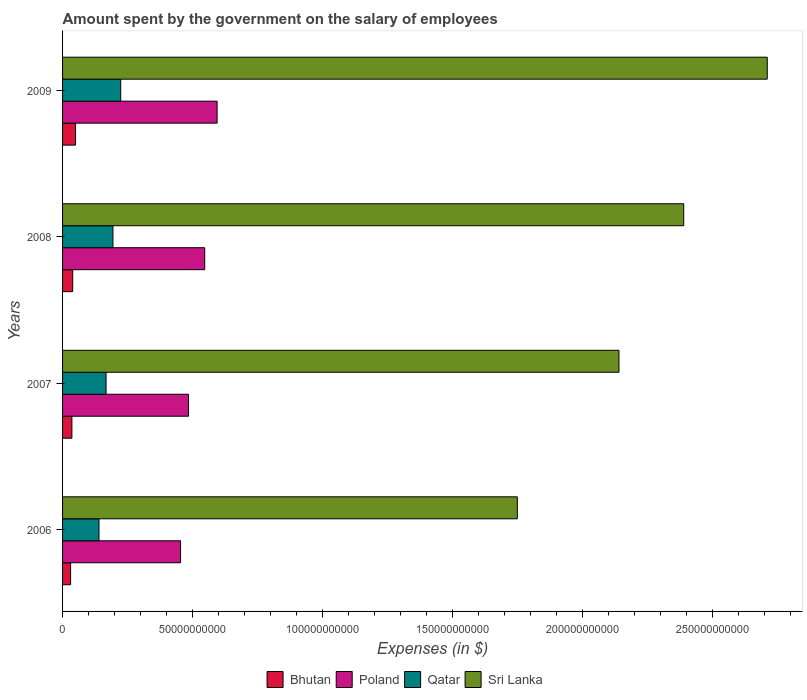What is the label of the 1st group of bars from the top?
Provide a short and direct response. 2009. What is the amount spent on the salary of employees by the government in Qatar in 2007?
Your response must be concise. 1.67e+1. Across all years, what is the maximum amount spent on the salary of employees by the government in Poland?
Your answer should be compact. 5.95e+1. Across all years, what is the minimum amount spent on the salary of employees by the government in Sri Lanka?
Provide a short and direct response. 1.75e+11. In which year was the amount spent on the salary of employees by the government in Poland minimum?
Make the answer very short. 2006. What is the total amount spent on the salary of employees by the government in Qatar in the graph?
Give a very brief answer. 7.25e+1. What is the difference between the amount spent on the salary of employees by the government in Sri Lanka in 2006 and that in 2009?
Your answer should be very brief. -9.62e+1. What is the difference between the amount spent on the salary of employees by the government in Poland in 2006 and the amount spent on the salary of employees by the government in Sri Lanka in 2009?
Offer a terse response. -2.26e+11. What is the average amount spent on the salary of employees by the government in Qatar per year?
Your response must be concise. 1.81e+1. In the year 2009, what is the difference between the amount spent on the salary of employees by the government in Qatar and amount spent on the salary of employees by the government in Sri Lanka?
Make the answer very short. -2.49e+11. What is the ratio of the amount spent on the salary of employees by the government in Bhutan in 2008 to that in 2009?
Provide a succinct answer. 0.78. Is the difference between the amount spent on the salary of employees by the government in Qatar in 2006 and 2008 greater than the difference between the amount spent on the salary of employees by the government in Sri Lanka in 2006 and 2008?
Your answer should be very brief. Yes. What is the difference between the highest and the second highest amount spent on the salary of employees by the government in Sri Lanka?
Offer a terse response. 3.22e+1. What is the difference between the highest and the lowest amount spent on the salary of employees by the government in Qatar?
Your answer should be compact. 8.36e+09. In how many years, is the amount spent on the salary of employees by the government in Qatar greater than the average amount spent on the salary of employees by the government in Qatar taken over all years?
Offer a terse response. 2. What does the 2nd bar from the top in 2008 represents?
Offer a very short reply. Qatar. What does the 4th bar from the bottom in 2008 represents?
Offer a very short reply. Sri Lanka. Is it the case that in every year, the sum of the amount spent on the salary of employees by the government in Poland and amount spent on the salary of employees by the government in Qatar is greater than the amount spent on the salary of employees by the government in Sri Lanka?
Offer a terse response. No. What is the difference between two consecutive major ticks on the X-axis?
Your response must be concise. 5.00e+1. Are the values on the major ticks of X-axis written in scientific E-notation?
Provide a succinct answer. No. Does the graph contain any zero values?
Offer a very short reply. No. Where does the legend appear in the graph?
Ensure brevity in your answer.  Bottom center. How many legend labels are there?
Offer a terse response. 4. What is the title of the graph?
Offer a very short reply. Amount spent by the government on the salary of employees. What is the label or title of the X-axis?
Ensure brevity in your answer.  Expenses (in $). What is the Expenses (in $) of Bhutan in 2006?
Offer a terse response. 3.09e+09. What is the Expenses (in $) in Poland in 2006?
Offer a terse response. 4.54e+1. What is the Expenses (in $) in Qatar in 2006?
Provide a short and direct response. 1.40e+1. What is the Expenses (in $) in Sri Lanka in 2006?
Your answer should be very brief. 1.75e+11. What is the Expenses (in $) of Bhutan in 2007?
Your answer should be very brief. 3.60e+09. What is the Expenses (in $) of Poland in 2007?
Your answer should be compact. 4.85e+1. What is the Expenses (in $) of Qatar in 2007?
Ensure brevity in your answer.  1.67e+1. What is the Expenses (in $) of Sri Lanka in 2007?
Your answer should be compact. 2.14e+11. What is the Expenses (in $) in Bhutan in 2008?
Your answer should be very brief. 3.90e+09. What is the Expenses (in $) of Poland in 2008?
Offer a very short reply. 5.47e+1. What is the Expenses (in $) of Qatar in 2008?
Provide a succinct answer. 1.94e+1. What is the Expenses (in $) in Sri Lanka in 2008?
Ensure brevity in your answer.  2.39e+11. What is the Expenses (in $) of Bhutan in 2009?
Give a very brief answer. 4.99e+09. What is the Expenses (in $) of Poland in 2009?
Provide a short and direct response. 5.95e+1. What is the Expenses (in $) in Qatar in 2009?
Your response must be concise. 2.24e+1. What is the Expenses (in $) in Sri Lanka in 2009?
Offer a terse response. 2.71e+11. Across all years, what is the maximum Expenses (in $) in Bhutan?
Offer a terse response. 4.99e+09. Across all years, what is the maximum Expenses (in $) in Poland?
Give a very brief answer. 5.95e+1. Across all years, what is the maximum Expenses (in $) in Qatar?
Your response must be concise. 2.24e+1. Across all years, what is the maximum Expenses (in $) of Sri Lanka?
Your response must be concise. 2.71e+11. Across all years, what is the minimum Expenses (in $) of Bhutan?
Ensure brevity in your answer.  3.09e+09. Across all years, what is the minimum Expenses (in $) in Poland?
Ensure brevity in your answer.  4.54e+1. Across all years, what is the minimum Expenses (in $) in Qatar?
Offer a terse response. 1.40e+1. Across all years, what is the minimum Expenses (in $) in Sri Lanka?
Offer a very short reply. 1.75e+11. What is the total Expenses (in $) of Bhutan in the graph?
Ensure brevity in your answer.  1.56e+1. What is the total Expenses (in $) in Poland in the graph?
Offer a very short reply. 2.08e+11. What is the total Expenses (in $) in Qatar in the graph?
Your answer should be very brief. 7.25e+1. What is the total Expenses (in $) in Sri Lanka in the graph?
Ensure brevity in your answer.  8.99e+11. What is the difference between the Expenses (in $) of Bhutan in 2006 and that in 2007?
Make the answer very short. -5.02e+08. What is the difference between the Expenses (in $) in Poland in 2006 and that in 2007?
Offer a terse response. -3.07e+09. What is the difference between the Expenses (in $) of Qatar in 2006 and that in 2007?
Provide a succinct answer. -2.72e+09. What is the difference between the Expenses (in $) in Sri Lanka in 2006 and that in 2007?
Give a very brief answer. -3.91e+1. What is the difference between the Expenses (in $) of Bhutan in 2006 and that in 2008?
Provide a short and direct response. -8.10e+08. What is the difference between the Expenses (in $) in Poland in 2006 and that in 2008?
Give a very brief answer. -9.30e+09. What is the difference between the Expenses (in $) in Qatar in 2006 and that in 2008?
Your answer should be very brief. -5.37e+09. What is the difference between the Expenses (in $) in Sri Lanka in 2006 and that in 2008?
Provide a short and direct response. -6.40e+1. What is the difference between the Expenses (in $) of Bhutan in 2006 and that in 2009?
Ensure brevity in your answer.  -1.90e+09. What is the difference between the Expenses (in $) of Poland in 2006 and that in 2009?
Give a very brief answer. -1.41e+1. What is the difference between the Expenses (in $) of Qatar in 2006 and that in 2009?
Provide a succinct answer. -8.36e+09. What is the difference between the Expenses (in $) of Sri Lanka in 2006 and that in 2009?
Your answer should be very brief. -9.62e+1. What is the difference between the Expenses (in $) of Bhutan in 2007 and that in 2008?
Your response must be concise. -3.08e+08. What is the difference between the Expenses (in $) in Poland in 2007 and that in 2008?
Your response must be concise. -6.23e+09. What is the difference between the Expenses (in $) in Qatar in 2007 and that in 2008?
Keep it short and to the point. -2.65e+09. What is the difference between the Expenses (in $) in Sri Lanka in 2007 and that in 2008?
Offer a very short reply. -2.49e+1. What is the difference between the Expenses (in $) of Bhutan in 2007 and that in 2009?
Provide a short and direct response. -1.40e+09. What is the difference between the Expenses (in $) of Poland in 2007 and that in 2009?
Your response must be concise. -1.10e+1. What is the difference between the Expenses (in $) in Qatar in 2007 and that in 2009?
Ensure brevity in your answer.  -5.64e+09. What is the difference between the Expenses (in $) in Sri Lanka in 2007 and that in 2009?
Give a very brief answer. -5.71e+1. What is the difference between the Expenses (in $) of Bhutan in 2008 and that in 2009?
Ensure brevity in your answer.  -1.09e+09. What is the difference between the Expenses (in $) in Poland in 2008 and that in 2009?
Offer a very short reply. -4.77e+09. What is the difference between the Expenses (in $) of Qatar in 2008 and that in 2009?
Your answer should be very brief. -2.99e+09. What is the difference between the Expenses (in $) of Sri Lanka in 2008 and that in 2009?
Offer a terse response. -3.22e+1. What is the difference between the Expenses (in $) of Bhutan in 2006 and the Expenses (in $) of Poland in 2007?
Your answer should be very brief. -4.54e+1. What is the difference between the Expenses (in $) in Bhutan in 2006 and the Expenses (in $) in Qatar in 2007?
Ensure brevity in your answer.  -1.36e+1. What is the difference between the Expenses (in $) of Bhutan in 2006 and the Expenses (in $) of Sri Lanka in 2007?
Make the answer very short. -2.11e+11. What is the difference between the Expenses (in $) of Poland in 2006 and the Expenses (in $) of Qatar in 2007?
Your answer should be very brief. 2.87e+1. What is the difference between the Expenses (in $) of Poland in 2006 and the Expenses (in $) of Sri Lanka in 2007?
Make the answer very short. -1.69e+11. What is the difference between the Expenses (in $) in Qatar in 2006 and the Expenses (in $) in Sri Lanka in 2007?
Offer a terse response. -2.00e+11. What is the difference between the Expenses (in $) of Bhutan in 2006 and the Expenses (in $) of Poland in 2008?
Ensure brevity in your answer.  -5.16e+1. What is the difference between the Expenses (in $) of Bhutan in 2006 and the Expenses (in $) of Qatar in 2008?
Give a very brief answer. -1.63e+1. What is the difference between the Expenses (in $) in Bhutan in 2006 and the Expenses (in $) in Sri Lanka in 2008?
Provide a succinct answer. -2.36e+11. What is the difference between the Expenses (in $) in Poland in 2006 and the Expenses (in $) in Qatar in 2008?
Offer a terse response. 2.60e+1. What is the difference between the Expenses (in $) in Poland in 2006 and the Expenses (in $) in Sri Lanka in 2008?
Your response must be concise. -1.94e+11. What is the difference between the Expenses (in $) in Qatar in 2006 and the Expenses (in $) in Sri Lanka in 2008?
Provide a succinct answer. -2.25e+11. What is the difference between the Expenses (in $) in Bhutan in 2006 and the Expenses (in $) in Poland in 2009?
Your response must be concise. -5.64e+1. What is the difference between the Expenses (in $) of Bhutan in 2006 and the Expenses (in $) of Qatar in 2009?
Your answer should be compact. -1.93e+1. What is the difference between the Expenses (in $) of Bhutan in 2006 and the Expenses (in $) of Sri Lanka in 2009?
Your answer should be very brief. -2.68e+11. What is the difference between the Expenses (in $) in Poland in 2006 and the Expenses (in $) in Qatar in 2009?
Provide a succinct answer. 2.30e+1. What is the difference between the Expenses (in $) in Poland in 2006 and the Expenses (in $) in Sri Lanka in 2009?
Your response must be concise. -2.26e+11. What is the difference between the Expenses (in $) in Qatar in 2006 and the Expenses (in $) in Sri Lanka in 2009?
Offer a terse response. -2.57e+11. What is the difference between the Expenses (in $) of Bhutan in 2007 and the Expenses (in $) of Poland in 2008?
Make the answer very short. -5.11e+1. What is the difference between the Expenses (in $) of Bhutan in 2007 and the Expenses (in $) of Qatar in 2008?
Ensure brevity in your answer.  -1.58e+1. What is the difference between the Expenses (in $) of Bhutan in 2007 and the Expenses (in $) of Sri Lanka in 2008?
Your answer should be compact. -2.35e+11. What is the difference between the Expenses (in $) in Poland in 2007 and the Expenses (in $) in Qatar in 2008?
Ensure brevity in your answer.  2.91e+1. What is the difference between the Expenses (in $) in Poland in 2007 and the Expenses (in $) in Sri Lanka in 2008?
Offer a terse response. -1.91e+11. What is the difference between the Expenses (in $) of Qatar in 2007 and the Expenses (in $) of Sri Lanka in 2008?
Ensure brevity in your answer.  -2.22e+11. What is the difference between the Expenses (in $) of Bhutan in 2007 and the Expenses (in $) of Poland in 2009?
Give a very brief answer. -5.59e+1. What is the difference between the Expenses (in $) in Bhutan in 2007 and the Expenses (in $) in Qatar in 2009?
Ensure brevity in your answer.  -1.88e+1. What is the difference between the Expenses (in $) in Bhutan in 2007 and the Expenses (in $) in Sri Lanka in 2009?
Make the answer very short. -2.68e+11. What is the difference between the Expenses (in $) in Poland in 2007 and the Expenses (in $) in Qatar in 2009?
Your answer should be very brief. 2.61e+1. What is the difference between the Expenses (in $) in Poland in 2007 and the Expenses (in $) in Sri Lanka in 2009?
Give a very brief answer. -2.23e+11. What is the difference between the Expenses (in $) of Qatar in 2007 and the Expenses (in $) of Sri Lanka in 2009?
Offer a very short reply. -2.54e+11. What is the difference between the Expenses (in $) of Bhutan in 2008 and the Expenses (in $) of Poland in 2009?
Provide a short and direct response. -5.56e+1. What is the difference between the Expenses (in $) of Bhutan in 2008 and the Expenses (in $) of Qatar in 2009?
Your answer should be compact. -1.85e+1. What is the difference between the Expenses (in $) of Bhutan in 2008 and the Expenses (in $) of Sri Lanka in 2009?
Give a very brief answer. -2.67e+11. What is the difference between the Expenses (in $) in Poland in 2008 and the Expenses (in $) in Qatar in 2009?
Give a very brief answer. 3.23e+1. What is the difference between the Expenses (in $) of Poland in 2008 and the Expenses (in $) of Sri Lanka in 2009?
Make the answer very short. -2.17e+11. What is the difference between the Expenses (in $) of Qatar in 2008 and the Expenses (in $) of Sri Lanka in 2009?
Your answer should be very brief. -2.52e+11. What is the average Expenses (in $) of Bhutan per year?
Your response must be concise. 3.90e+09. What is the average Expenses (in $) in Poland per year?
Make the answer very short. 5.20e+1. What is the average Expenses (in $) in Qatar per year?
Provide a short and direct response. 1.81e+1. What is the average Expenses (in $) in Sri Lanka per year?
Keep it short and to the point. 2.25e+11. In the year 2006, what is the difference between the Expenses (in $) in Bhutan and Expenses (in $) in Poland?
Provide a succinct answer. -4.23e+1. In the year 2006, what is the difference between the Expenses (in $) in Bhutan and Expenses (in $) in Qatar?
Your answer should be compact. -1.09e+1. In the year 2006, what is the difference between the Expenses (in $) in Bhutan and Expenses (in $) in Sri Lanka?
Provide a succinct answer. -1.72e+11. In the year 2006, what is the difference between the Expenses (in $) in Poland and Expenses (in $) in Qatar?
Provide a succinct answer. 3.14e+1. In the year 2006, what is the difference between the Expenses (in $) in Poland and Expenses (in $) in Sri Lanka?
Your response must be concise. -1.30e+11. In the year 2006, what is the difference between the Expenses (in $) of Qatar and Expenses (in $) of Sri Lanka?
Offer a terse response. -1.61e+11. In the year 2007, what is the difference between the Expenses (in $) of Bhutan and Expenses (in $) of Poland?
Keep it short and to the point. -4.49e+1. In the year 2007, what is the difference between the Expenses (in $) of Bhutan and Expenses (in $) of Qatar?
Keep it short and to the point. -1.31e+1. In the year 2007, what is the difference between the Expenses (in $) of Bhutan and Expenses (in $) of Sri Lanka?
Provide a short and direct response. -2.11e+11. In the year 2007, what is the difference between the Expenses (in $) in Poland and Expenses (in $) in Qatar?
Keep it short and to the point. 3.17e+1. In the year 2007, what is the difference between the Expenses (in $) in Poland and Expenses (in $) in Sri Lanka?
Keep it short and to the point. -1.66e+11. In the year 2007, what is the difference between the Expenses (in $) of Qatar and Expenses (in $) of Sri Lanka?
Provide a short and direct response. -1.97e+11. In the year 2008, what is the difference between the Expenses (in $) of Bhutan and Expenses (in $) of Poland?
Your response must be concise. -5.08e+1. In the year 2008, what is the difference between the Expenses (in $) in Bhutan and Expenses (in $) in Qatar?
Make the answer very short. -1.55e+1. In the year 2008, what is the difference between the Expenses (in $) of Bhutan and Expenses (in $) of Sri Lanka?
Your response must be concise. -2.35e+11. In the year 2008, what is the difference between the Expenses (in $) of Poland and Expenses (in $) of Qatar?
Offer a terse response. 3.53e+1. In the year 2008, what is the difference between the Expenses (in $) in Poland and Expenses (in $) in Sri Lanka?
Keep it short and to the point. -1.84e+11. In the year 2008, what is the difference between the Expenses (in $) in Qatar and Expenses (in $) in Sri Lanka?
Give a very brief answer. -2.20e+11. In the year 2009, what is the difference between the Expenses (in $) of Bhutan and Expenses (in $) of Poland?
Keep it short and to the point. -5.45e+1. In the year 2009, what is the difference between the Expenses (in $) of Bhutan and Expenses (in $) of Qatar?
Provide a short and direct response. -1.74e+1. In the year 2009, what is the difference between the Expenses (in $) of Bhutan and Expenses (in $) of Sri Lanka?
Offer a terse response. -2.66e+11. In the year 2009, what is the difference between the Expenses (in $) in Poland and Expenses (in $) in Qatar?
Keep it short and to the point. 3.71e+1. In the year 2009, what is the difference between the Expenses (in $) in Poland and Expenses (in $) in Sri Lanka?
Provide a short and direct response. -2.12e+11. In the year 2009, what is the difference between the Expenses (in $) of Qatar and Expenses (in $) of Sri Lanka?
Provide a short and direct response. -2.49e+11. What is the ratio of the Expenses (in $) in Bhutan in 2006 to that in 2007?
Ensure brevity in your answer.  0.86. What is the ratio of the Expenses (in $) in Poland in 2006 to that in 2007?
Your answer should be very brief. 0.94. What is the ratio of the Expenses (in $) of Qatar in 2006 to that in 2007?
Your response must be concise. 0.84. What is the ratio of the Expenses (in $) of Sri Lanka in 2006 to that in 2007?
Make the answer very short. 0.82. What is the ratio of the Expenses (in $) in Bhutan in 2006 to that in 2008?
Keep it short and to the point. 0.79. What is the ratio of the Expenses (in $) in Poland in 2006 to that in 2008?
Ensure brevity in your answer.  0.83. What is the ratio of the Expenses (in $) in Qatar in 2006 to that in 2008?
Your response must be concise. 0.72. What is the ratio of the Expenses (in $) in Sri Lanka in 2006 to that in 2008?
Your answer should be very brief. 0.73. What is the ratio of the Expenses (in $) of Bhutan in 2006 to that in 2009?
Offer a very short reply. 0.62. What is the ratio of the Expenses (in $) in Poland in 2006 to that in 2009?
Your answer should be very brief. 0.76. What is the ratio of the Expenses (in $) of Qatar in 2006 to that in 2009?
Give a very brief answer. 0.63. What is the ratio of the Expenses (in $) in Sri Lanka in 2006 to that in 2009?
Keep it short and to the point. 0.65. What is the ratio of the Expenses (in $) in Bhutan in 2007 to that in 2008?
Provide a short and direct response. 0.92. What is the ratio of the Expenses (in $) of Poland in 2007 to that in 2008?
Give a very brief answer. 0.89. What is the ratio of the Expenses (in $) in Qatar in 2007 to that in 2008?
Give a very brief answer. 0.86. What is the ratio of the Expenses (in $) in Sri Lanka in 2007 to that in 2008?
Your answer should be very brief. 0.9. What is the ratio of the Expenses (in $) of Bhutan in 2007 to that in 2009?
Offer a terse response. 0.72. What is the ratio of the Expenses (in $) of Poland in 2007 to that in 2009?
Provide a succinct answer. 0.82. What is the ratio of the Expenses (in $) of Qatar in 2007 to that in 2009?
Keep it short and to the point. 0.75. What is the ratio of the Expenses (in $) in Sri Lanka in 2007 to that in 2009?
Provide a short and direct response. 0.79. What is the ratio of the Expenses (in $) in Bhutan in 2008 to that in 2009?
Your answer should be compact. 0.78. What is the ratio of the Expenses (in $) in Poland in 2008 to that in 2009?
Give a very brief answer. 0.92. What is the ratio of the Expenses (in $) in Qatar in 2008 to that in 2009?
Offer a terse response. 0.87. What is the ratio of the Expenses (in $) in Sri Lanka in 2008 to that in 2009?
Provide a short and direct response. 0.88. What is the difference between the highest and the second highest Expenses (in $) of Bhutan?
Ensure brevity in your answer.  1.09e+09. What is the difference between the highest and the second highest Expenses (in $) of Poland?
Offer a terse response. 4.77e+09. What is the difference between the highest and the second highest Expenses (in $) in Qatar?
Make the answer very short. 2.99e+09. What is the difference between the highest and the second highest Expenses (in $) in Sri Lanka?
Offer a terse response. 3.22e+1. What is the difference between the highest and the lowest Expenses (in $) of Bhutan?
Make the answer very short. 1.90e+09. What is the difference between the highest and the lowest Expenses (in $) in Poland?
Your answer should be very brief. 1.41e+1. What is the difference between the highest and the lowest Expenses (in $) in Qatar?
Your answer should be very brief. 8.36e+09. What is the difference between the highest and the lowest Expenses (in $) in Sri Lanka?
Offer a terse response. 9.62e+1. 